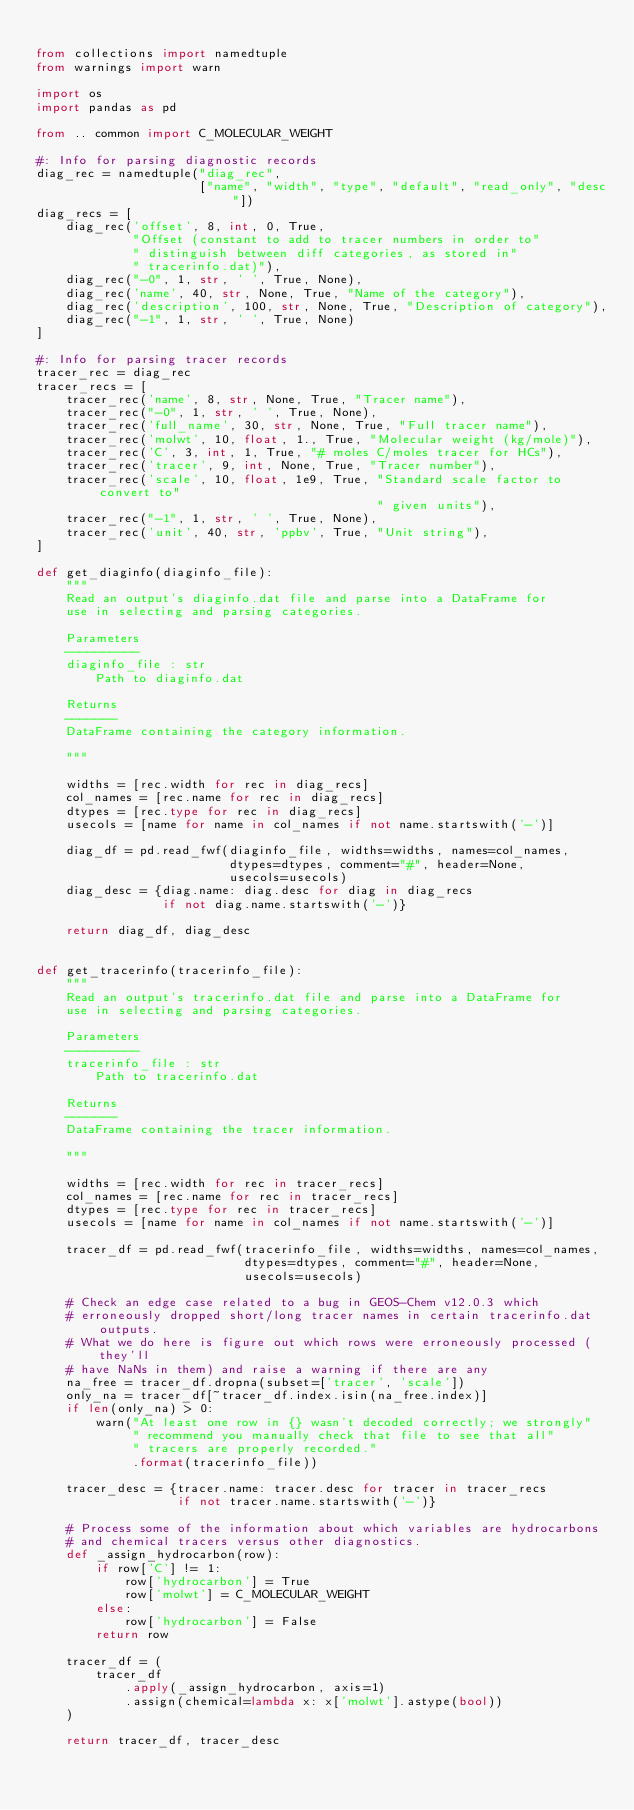Convert code to text. <code><loc_0><loc_0><loc_500><loc_500><_Python_>
from collections import namedtuple
from warnings import warn

import os
import pandas as pd

from .. common import C_MOLECULAR_WEIGHT

#: Info for parsing diagnostic records
diag_rec = namedtuple("diag_rec",
                      ["name", "width", "type", "default", "read_only", "desc"])
diag_recs = [
    diag_rec('offset', 8, int, 0, True,
             "Offset (constant to add to tracer numbers in order to"
             " distinguish between diff categories, as stored in"
             " tracerinfo.dat)"),
    diag_rec("-0", 1, str, ' ', True, None),
    diag_rec('name', 40, str, None, True, "Name of the category"),
    diag_rec('description', 100, str, None, True, "Description of category"),
    diag_rec("-1", 1, str, ' ', True, None)
]

#: Info for parsing tracer records
tracer_rec = diag_rec
tracer_recs = [
    tracer_rec('name', 8, str, None, True, "Tracer name"),
    tracer_rec("-0", 1, str, ' ', True, None),
    tracer_rec('full_name', 30, str, None, True, "Full tracer name"),
    tracer_rec('molwt', 10, float, 1., True, "Molecular weight (kg/mole)"),
    tracer_rec('C', 3, int, 1, True, "# moles C/moles tracer for HCs"),
    tracer_rec('tracer', 9, int, None, True, "Tracer number"),
    tracer_rec('scale', 10, float, 1e9, True, "Standard scale factor to convert to"
                                              " given units"),
    tracer_rec("-1", 1, str, ' ', True, None),
    tracer_rec('unit', 40, str, 'ppbv', True, "Unit string"),
]

def get_diaginfo(diaginfo_file):
    """
    Read an output's diaginfo.dat file and parse into a DataFrame for
    use in selecting and parsing categories.

    Parameters
    ----------
    diaginfo_file : str
        Path to diaginfo.dat

    Returns
    -------
    DataFrame containing the category information.

    """

    widths = [rec.width for rec in diag_recs]
    col_names = [rec.name for rec in diag_recs]
    dtypes = [rec.type for rec in diag_recs]
    usecols = [name for name in col_names if not name.startswith('-')]

    diag_df = pd.read_fwf(diaginfo_file, widths=widths, names=col_names,
                          dtypes=dtypes, comment="#", header=None,
                          usecols=usecols)
    diag_desc = {diag.name: diag.desc for diag in diag_recs
                 if not diag.name.startswith('-')}

    return diag_df, diag_desc


def get_tracerinfo(tracerinfo_file):
    """
    Read an output's tracerinfo.dat file and parse into a DataFrame for
    use in selecting and parsing categories.

    Parameters
    ----------
    tracerinfo_file : str
        Path to tracerinfo.dat

    Returns
    -------
    DataFrame containing the tracer information.

    """

    widths = [rec.width for rec in tracer_recs]
    col_names = [rec.name for rec in tracer_recs]
    dtypes = [rec.type for rec in tracer_recs]
    usecols = [name for name in col_names if not name.startswith('-')]

    tracer_df = pd.read_fwf(tracerinfo_file, widths=widths, names=col_names,
                            dtypes=dtypes, comment="#", header=None,
                            usecols=usecols)

    # Check an edge case related to a bug in GEOS-Chem v12.0.3 which 
    # erroneously dropped short/long tracer names in certain tracerinfo.dat outputs.
    # What we do here is figure out which rows were erroneously processed (they'll 
    # have NaNs in them) and raise a warning if there are any
    na_free = tracer_df.dropna(subset=['tracer', 'scale'])
    only_na = tracer_df[~tracer_df.index.isin(na_free.index)]
    if len(only_na) > 0:
        warn("At least one row in {} wasn't decoded correctly; we strongly"
             " recommend you manually check that file to see that all"
             " tracers are properly recorded."
             .format(tracerinfo_file)) 

    tracer_desc = {tracer.name: tracer.desc for tracer in tracer_recs
                   if not tracer.name.startswith('-')}

    # Process some of the information about which variables are hydrocarbons
    # and chemical tracers versus other diagnostics.
    def _assign_hydrocarbon(row):
        if row['C'] != 1:
            row['hydrocarbon'] = True
            row['molwt'] = C_MOLECULAR_WEIGHT
        else:
            row['hydrocarbon'] = False
        return row

    tracer_df = (
        tracer_df
            .apply(_assign_hydrocarbon, axis=1)
            .assign(chemical=lambda x: x['molwt'].astype(bool))
    )

    return tracer_df, tracer_desc</code> 